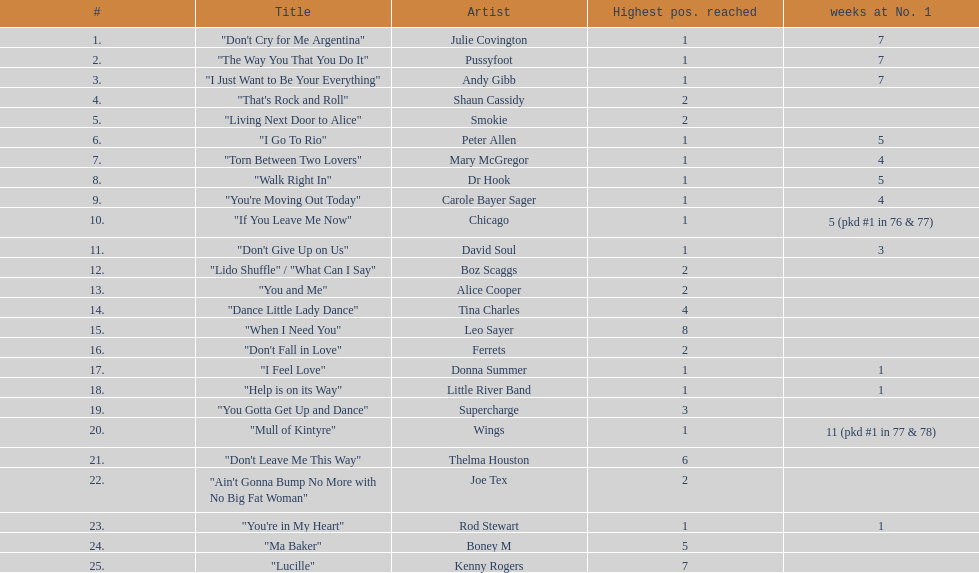How many weeks did julie covington's "don't cry for me argentina" spend at the top of australia's singles chart? 7. 